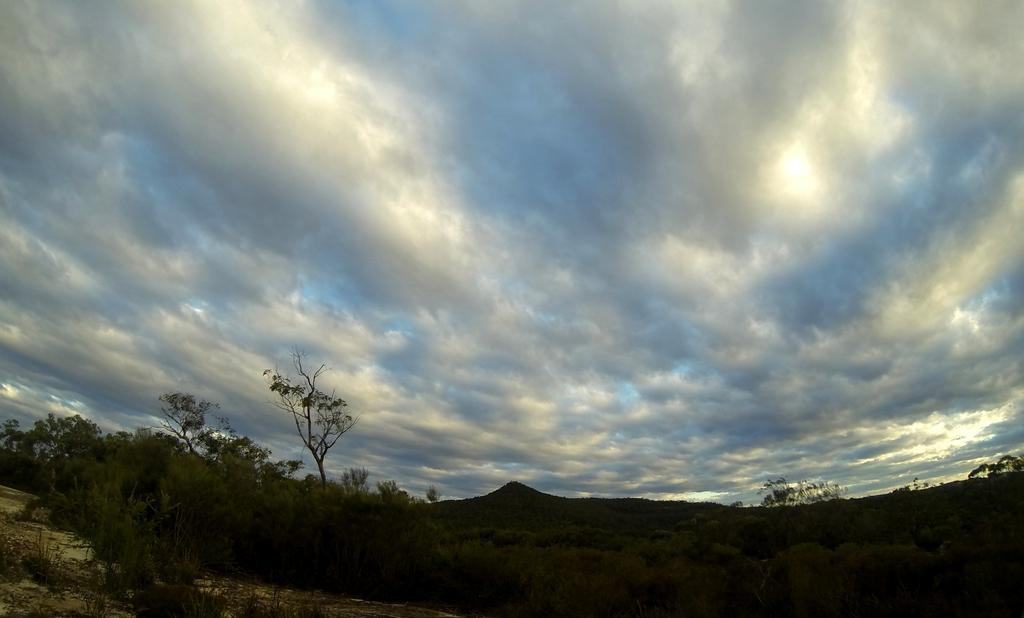What type of vegetation is present in the image? There are many trees in the image. What can be seen in the sky in the image? There are clouds visible at the top of the image. Is there a writer sitting on a bike while flying a kite in the image? No, there is no writer, bike, or kite present in the image. 